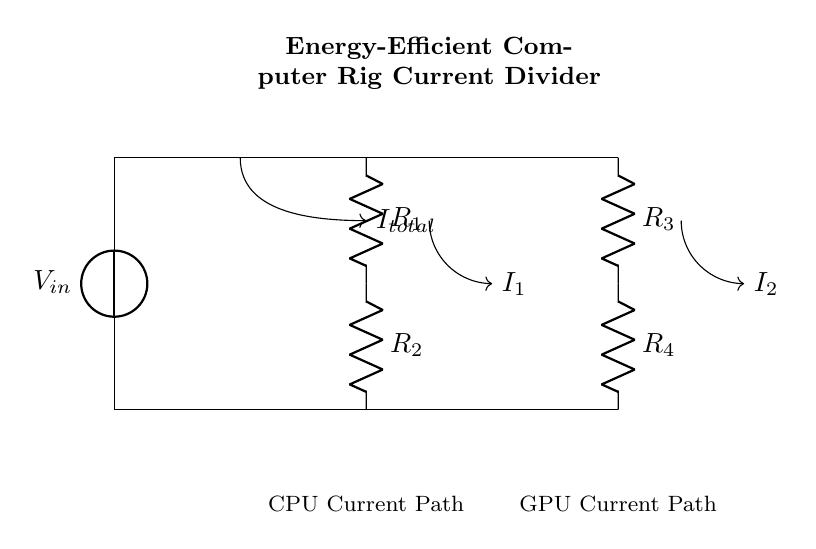What is the input voltage of the circuit? The input voltage is represented by the component labeled \(V_{in}\) at the top of the circuit diagram.
Answer: \(V_{in}\) What are the resistors used in this circuit? The resistors are labeled \(R_1\), \(R_2\), \(R_3\), and \(R_4\), which are connected in parallel and series configurations within the circuit.
Answer: \(R_1, R_2, R_3, R_4\) What is the total current entering the circuit? The total current entering the circuit is indicated by the label \(I_{total}\) at the input side before the current splits.
Answer: \(I_{total}\) Which path features the CPU in the circuit? The path leading down from \(R_1\) and \(R_2\) is marked as the “CPU Current Path,” indicating where the CPU receives its current.
Answer: CPU Current Path How can you determine the current through \(R_1\)? To determine the current through \(R_1\), you can apply the current divider rule. The current splits proportionally across the parallel resistors \(R_1\) and \(R_2\) based on their resistances.
Answer: \(I_1\) What configuration do the resistors form in this circuit? The configuration for the resistors \(R_1\) and \(R_2\) is in parallel, which divides the current, while \(R_3\) and \(R_4\) are also in parallel in the lower path.
Answer: Parallel What is the function of the current divider in this circuit? The current divider's function is to efficiently split the total current between multiple paths, optimizing current flow to different components, like the CPU and GPU.
Answer: Balancing current flow 